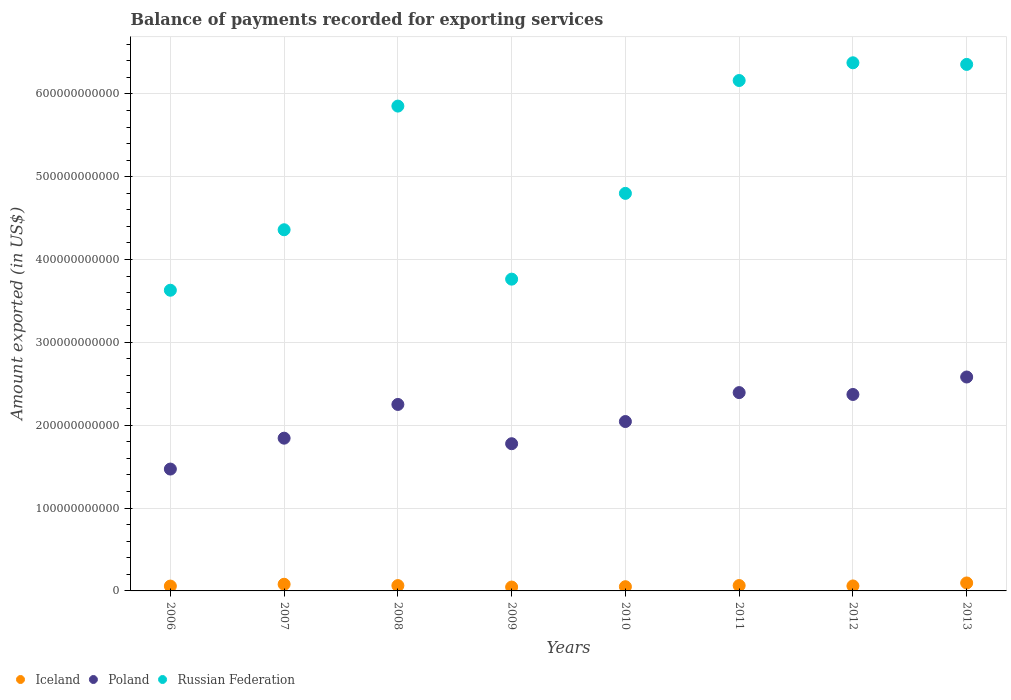How many different coloured dotlines are there?
Your answer should be very brief. 3. What is the amount exported in Russian Federation in 2012?
Offer a terse response. 6.38e+11. Across all years, what is the maximum amount exported in Poland?
Ensure brevity in your answer.  2.58e+11. Across all years, what is the minimum amount exported in Iceland?
Provide a succinct answer. 4.67e+09. In which year was the amount exported in Iceland maximum?
Provide a short and direct response. 2013. In which year was the amount exported in Poland minimum?
Offer a terse response. 2006. What is the total amount exported in Iceland in the graph?
Offer a terse response. 5.22e+1. What is the difference between the amount exported in Russian Federation in 2008 and that in 2011?
Offer a terse response. -3.09e+1. What is the difference between the amount exported in Iceland in 2013 and the amount exported in Russian Federation in 2009?
Your response must be concise. -3.67e+11. What is the average amount exported in Iceland per year?
Provide a succinct answer. 6.52e+09. In the year 2007, what is the difference between the amount exported in Iceland and amount exported in Russian Federation?
Give a very brief answer. -4.28e+11. In how many years, is the amount exported in Poland greater than 400000000000 US$?
Provide a succinct answer. 0. What is the ratio of the amount exported in Iceland in 2007 to that in 2008?
Your response must be concise. 1.25. Is the amount exported in Iceland in 2007 less than that in 2013?
Your answer should be compact. Yes. Is the difference between the amount exported in Iceland in 2010 and 2013 greater than the difference between the amount exported in Russian Federation in 2010 and 2013?
Provide a succinct answer. Yes. What is the difference between the highest and the second highest amount exported in Poland?
Your response must be concise. 1.88e+1. What is the difference between the highest and the lowest amount exported in Iceland?
Offer a very short reply. 4.95e+09. Does the amount exported in Iceland monotonically increase over the years?
Provide a succinct answer. No. What is the difference between two consecutive major ticks on the Y-axis?
Make the answer very short. 1.00e+11. Does the graph contain any zero values?
Keep it short and to the point. No. How are the legend labels stacked?
Give a very brief answer. Horizontal. What is the title of the graph?
Keep it short and to the point. Balance of payments recorded for exporting services. What is the label or title of the X-axis?
Ensure brevity in your answer.  Years. What is the label or title of the Y-axis?
Your answer should be compact. Amount exported (in US$). What is the Amount exported (in US$) of Iceland in 2006?
Your answer should be very brief. 5.86e+09. What is the Amount exported (in US$) of Poland in 2006?
Give a very brief answer. 1.47e+11. What is the Amount exported (in US$) of Russian Federation in 2006?
Give a very brief answer. 3.63e+11. What is the Amount exported (in US$) in Iceland in 2007?
Provide a short and direct response. 8.03e+09. What is the Amount exported (in US$) in Poland in 2007?
Provide a short and direct response. 1.84e+11. What is the Amount exported (in US$) in Russian Federation in 2007?
Ensure brevity in your answer.  4.36e+11. What is the Amount exported (in US$) in Iceland in 2008?
Provide a short and direct response. 6.43e+09. What is the Amount exported (in US$) in Poland in 2008?
Keep it short and to the point. 2.25e+11. What is the Amount exported (in US$) in Russian Federation in 2008?
Provide a succinct answer. 5.85e+11. What is the Amount exported (in US$) in Iceland in 2009?
Make the answer very short. 4.67e+09. What is the Amount exported (in US$) of Poland in 2009?
Provide a short and direct response. 1.78e+11. What is the Amount exported (in US$) in Russian Federation in 2009?
Ensure brevity in your answer.  3.76e+11. What is the Amount exported (in US$) of Iceland in 2010?
Ensure brevity in your answer.  5.08e+09. What is the Amount exported (in US$) of Poland in 2010?
Ensure brevity in your answer.  2.04e+11. What is the Amount exported (in US$) of Russian Federation in 2010?
Keep it short and to the point. 4.80e+11. What is the Amount exported (in US$) of Iceland in 2011?
Provide a short and direct response. 6.49e+09. What is the Amount exported (in US$) of Poland in 2011?
Your answer should be compact. 2.39e+11. What is the Amount exported (in US$) in Russian Federation in 2011?
Offer a terse response. 6.16e+11. What is the Amount exported (in US$) in Iceland in 2012?
Offer a very short reply. 6.00e+09. What is the Amount exported (in US$) in Poland in 2012?
Keep it short and to the point. 2.37e+11. What is the Amount exported (in US$) of Russian Federation in 2012?
Your response must be concise. 6.38e+11. What is the Amount exported (in US$) of Iceland in 2013?
Provide a succinct answer. 9.62e+09. What is the Amount exported (in US$) in Poland in 2013?
Keep it short and to the point. 2.58e+11. What is the Amount exported (in US$) of Russian Federation in 2013?
Your response must be concise. 6.36e+11. Across all years, what is the maximum Amount exported (in US$) in Iceland?
Provide a short and direct response. 9.62e+09. Across all years, what is the maximum Amount exported (in US$) in Poland?
Give a very brief answer. 2.58e+11. Across all years, what is the maximum Amount exported (in US$) in Russian Federation?
Ensure brevity in your answer.  6.38e+11. Across all years, what is the minimum Amount exported (in US$) of Iceland?
Provide a short and direct response. 4.67e+09. Across all years, what is the minimum Amount exported (in US$) in Poland?
Provide a succinct answer. 1.47e+11. Across all years, what is the minimum Amount exported (in US$) in Russian Federation?
Offer a very short reply. 3.63e+11. What is the total Amount exported (in US$) of Iceland in the graph?
Ensure brevity in your answer.  5.22e+1. What is the total Amount exported (in US$) of Poland in the graph?
Provide a succinct answer. 1.67e+12. What is the total Amount exported (in US$) in Russian Federation in the graph?
Your answer should be very brief. 4.13e+12. What is the difference between the Amount exported (in US$) in Iceland in 2006 and that in 2007?
Offer a terse response. -2.17e+09. What is the difference between the Amount exported (in US$) of Poland in 2006 and that in 2007?
Ensure brevity in your answer.  -3.73e+1. What is the difference between the Amount exported (in US$) in Russian Federation in 2006 and that in 2007?
Provide a short and direct response. -7.30e+1. What is the difference between the Amount exported (in US$) in Iceland in 2006 and that in 2008?
Make the answer very short. -5.76e+08. What is the difference between the Amount exported (in US$) of Poland in 2006 and that in 2008?
Your answer should be very brief. -7.80e+1. What is the difference between the Amount exported (in US$) of Russian Federation in 2006 and that in 2008?
Your response must be concise. -2.22e+11. What is the difference between the Amount exported (in US$) in Iceland in 2006 and that in 2009?
Ensure brevity in your answer.  1.19e+09. What is the difference between the Amount exported (in US$) in Poland in 2006 and that in 2009?
Offer a terse response. -3.06e+1. What is the difference between the Amount exported (in US$) in Russian Federation in 2006 and that in 2009?
Offer a very short reply. -1.34e+1. What is the difference between the Amount exported (in US$) of Iceland in 2006 and that in 2010?
Your answer should be compact. 7.73e+08. What is the difference between the Amount exported (in US$) in Poland in 2006 and that in 2010?
Provide a succinct answer. -5.74e+1. What is the difference between the Amount exported (in US$) in Russian Federation in 2006 and that in 2010?
Your answer should be compact. -1.17e+11. What is the difference between the Amount exported (in US$) in Iceland in 2006 and that in 2011?
Offer a terse response. -6.27e+08. What is the difference between the Amount exported (in US$) of Poland in 2006 and that in 2011?
Ensure brevity in your answer.  -9.23e+1. What is the difference between the Amount exported (in US$) of Russian Federation in 2006 and that in 2011?
Provide a short and direct response. -2.53e+11. What is the difference between the Amount exported (in US$) in Iceland in 2006 and that in 2012?
Give a very brief answer. -1.45e+08. What is the difference between the Amount exported (in US$) of Poland in 2006 and that in 2012?
Your response must be concise. -9.00e+1. What is the difference between the Amount exported (in US$) in Russian Federation in 2006 and that in 2012?
Ensure brevity in your answer.  -2.75e+11. What is the difference between the Amount exported (in US$) of Iceland in 2006 and that in 2013?
Provide a short and direct response. -3.76e+09. What is the difference between the Amount exported (in US$) in Poland in 2006 and that in 2013?
Offer a terse response. -1.11e+11. What is the difference between the Amount exported (in US$) in Russian Federation in 2006 and that in 2013?
Provide a short and direct response. -2.73e+11. What is the difference between the Amount exported (in US$) of Iceland in 2007 and that in 2008?
Your response must be concise. 1.60e+09. What is the difference between the Amount exported (in US$) of Poland in 2007 and that in 2008?
Your response must be concise. -4.07e+1. What is the difference between the Amount exported (in US$) in Russian Federation in 2007 and that in 2008?
Your answer should be compact. -1.49e+11. What is the difference between the Amount exported (in US$) in Iceland in 2007 and that in 2009?
Your answer should be compact. 3.36e+09. What is the difference between the Amount exported (in US$) of Poland in 2007 and that in 2009?
Offer a very short reply. 6.70e+09. What is the difference between the Amount exported (in US$) of Russian Federation in 2007 and that in 2009?
Give a very brief answer. 5.96e+1. What is the difference between the Amount exported (in US$) in Iceland in 2007 and that in 2010?
Provide a short and direct response. 2.94e+09. What is the difference between the Amount exported (in US$) of Poland in 2007 and that in 2010?
Make the answer very short. -2.01e+1. What is the difference between the Amount exported (in US$) in Russian Federation in 2007 and that in 2010?
Your answer should be compact. -4.39e+1. What is the difference between the Amount exported (in US$) in Iceland in 2007 and that in 2011?
Your response must be concise. 1.54e+09. What is the difference between the Amount exported (in US$) of Poland in 2007 and that in 2011?
Make the answer very short. -5.50e+1. What is the difference between the Amount exported (in US$) in Russian Federation in 2007 and that in 2011?
Make the answer very short. -1.80e+11. What is the difference between the Amount exported (in US$) of Iceland in 2007 and that in 2012?
Offer a terse response. 2.03e+09. What is the difference between the Amount exported (in US$) in Poland in 2007 and that in 2012?
Provide a short and direct response. -5.28e+1. What is the difference between the Amount exported (in US$) in Russian Federation in 2007 and that in 2012?
Make the answer very short. -2.02e+11. What is the difference between the Amount exported (in US$) of Iceland in 2007 and that in 2013?
Give a very brief answer. -1.59e+09. What is the difference between the Amount exported (in US$) in Poland in 2007 and that in 2013?
Your answer should be compact. -7.38e+1. What is the difference between the Amount exported (in US$) of Russian Federation in 2007 and that in 2013?
Your answer should be very brief. -2.00e+11. What is the difference between the Amount exported (in US$) in Iceland in 2008 and that in 2009?
Your answer should be compact. 1.77e+09. What is the difference between the Amount exported (in US$) in Poland in 2008 and that in 2009?
Provide a short and direct response. 4.74e+1. What is the difference between the Amount exported (in US$) in Russian Federation in 2008 and that in 2009?
Provide a succinct answer. 2.09e+11. What is the difference between the Amount exported (in US$) in Iceland in 2008 and that in 2010?
Keep it short and to the point. 1.35e+09. What is the difference between the Amount exported (in US$) of Poland in 2008 and that in 2010?
Ensure brevity in your answer.  2.06e+1. What is the difference between the Amount exported (in US$) of Russian Federation in 2008 and that in 2010?
Your answer should be very brief. 1.05e+11. What is the difference between the Amount exported (in US$) of Iceland in 2008 and that in 2011?
Make the answer very short. -5.18e+07. What is the difference between the Amount exported (in US$) of Poland in 2008 and that in 2011?
Give a very brief answer. -1.43e+1. What is the difference between the Amount exported (in US$) of Russian Federation in 2008 and that in 2011?
Offer a very short reply. -3.09e+1. What is the difference between the Amount exported (in US$) in Iceland in 2008 and that in 2012?
Ensure brevity in your answer.  4.31e+08. What is the difference between the Amount exported (in US$) in Poland in 2008 and that in 2012?
Your answer should be compact. -1.20e+1. What is the difference between the Amount exported (in US$) in Russian Federation in 2008 and that in 2012?
Your response must be concise. -5.23e+1. What is the difference between the Amount exported (in US$) of Iceland in 2008 and that in 2013?
Make the answer very short. -3.18e+09. What is the difference between the Amount exported (in US$) in Poland in 2008 and that in 2013?
Make the answer very short. -3.31e+1. What is the difference between the Amount exported (in US$) of Russian Federation in 2008 and that in 2013?
Offer a very short reply. -5.03e+1. What is the difference between the Amount exported (in US$) in Iceland in 2009 and that in 2010?
Provide a succinct answer. -4.17e+08. What is the difference between the Amount exported (in US$) of Poland in 2009 and that in 2010?
Keep it short and to the point. -2.68e+1. What is the difference between the Amount exported (in US$) of Russian Federation in 2009 and that in 2010?
Keep it short and to the point. -1.04e+11. What is the difference between the Amount exported (in US$) of Iceland in 2009 and that in 2011?
Give a very brief answer. -1.82e+09. What is the difference between the Amount exported (in US$) of Poland in 2009 and that in 2011?
Offer a very short reply. -6.17e+1. What is the difference between the Amount exported (in US$) in Russian Federation in 2009 and that in 2011?
Offer a terse response. -2.40e+11. What is the difference between the Amount exported (in US$) in Iceland in 2009 and that in 2012?
Keep it short and to the point. -1.33e+09. What is the difference between the Amount exported (in US$) in Poland in 2009 and that in 2012?
Your answer should be very brief. -5.95e+1. What is the difference between the Amount exported (in US$) of Russian Federation in 2009 and that in 2012?
Ensure brevity in your answer.  -2.61e+11. What is the difference between the Amount exported (in US$) in Iceland in 2009 and that in 2013?
Make the answer very short. -4.95e+09. What is the difference between the Amount exported (in US$) of Poland in 2009 and that in 2013?
Your answer should be very brief. -8.05e+1. What is the difference between the Amount exported (in US$) in Russian Federation in 2009 and that in 2013?
Your response must be concise. -2.59e+11. What is the difference between the Amount exported (in US$) of Iceland in 2010 and that in 2011?
Your response must be concise. -1.40e+09. What is the difference between the Amount exported (in US$) of Poland in 2010 and that in 2011?
Your response must be concise. -3.49e+1. What is the difference between the Amount exported (in US$) in Russian Federation in 2010 and that in 2011?
Your response must be concise. -1.36e+11. What is the difference between the Amount exported (in US$) of Iceland in 2010 and that in 2012?
Your answer should be very brief. -9.18e+08. What is the difference between the Amount exported (in US$) of Poland in 2010 and that in 2012?
Offer a terse response. -3.27e+1. What is the difference between the Amount exported (in US$) in Russian Federation in 2010 and that in 2012?
Your response must be concise. -1.58e+11. What is the difference between the Amount exported (in US$) in Iceland in 2010 and that in 2013?
Your answer should be compact. -4.53e+09. What is the difference between the Amount exported (in US$) in Poland in 2010 and that in 2013?
Your answer should be very brief. -5.37e+1. What is the difference between the Amount exported (in US$) in Russian Federation in 2010 and that in 2013?
Give a very brief answer. -1.56e+11. What is the difference between the Amount exported (in US$) in Iceland in 2011 and that in 2012?
Offer a terse response. 4.83e+08. What is the difference between the Amount exported (in US$) of Poland in 2011 and that in 2012?
Ensure brevity in your answer.  2.25e+09. What is the difference between the Amount exported (in US$) in Russian Federation in 2011 and that in 2012?
Your answer should be very brief. -2.14e+1. What is the difference between the Amount exported (in US$) of Iceland in 2011 and that in 2013?
Offer a terse response. -3.13e+09. What is the difference between the Amount exported (in US$) of Poland in 2011 and that in 2013?
Provide a succinct answer. -1.88e+1. What is the difference between the Amount exported (in US$) in Russian Federation in 2011 and that in 2013?
Your answer should be compact. -1.94e+1. What is the difference between the Amount exported (in US$) of Iceland in 2012 and that in 2013?
Ensure brevity in your answer.  -3.61e+09. What is the difference between the Amount exported (in US$) in Poland in 2012 and that in 2013?
Give a very brief answer. -2.11e+1. What is the difference between the Amount exported (in US$) in Russian Federation in 2012 and that in 2013?
Make the answer very short. 1.96e+09. What is the difference between the Amount exported (in US$) in Iceland in 2006 and the Amount exported (in US$) in Poland in 2007?
Your answer should be compact. -1.79e+11. What is the difference between the Amount exported (in US$) in Iceland in 2006 and the Amount exported (in US$) in Russian Federation in 2007?
Make the answer very short. -4.30e+11. What is the difference between the Amount exported (in US$) of Poland in 2006 and the Amount exported (in US$) of Russian Federation in 2007?
Provide a short and direct response. -2.89e+11. What is the difference between the Amount exported (in US$) in Iceland in 2006 and the Amount exported (in US$) in Poland in 2008?
Keep it short and to the point. -2.19e+11. What is the difference between the Amount exported (in US$) of Iceland in 2006 and the Amount exported (in US$) of Russian Federation in 2008?
Your response must be concise. -5.79e+11. What is the difference between the Amount exported (in US$) in Poland in 2006 and the Amount exported (in US$) in Russian Federation in 2008?
Provide a succinct answer. -4.38e+11. What is the difference between the Amount exported (in US$) in Iceland in 2006 and the Amount exported (in US$) in Poland in 2009?
Your answer should be very brief. -1.72e+11. What is the difference between the Amount exported (in US$) of Iceland in 2006 and the Amount exported (in US$) of Russian Federation in 2009?
Make the answer very short. -3.70e+11. What is the difference between the Amount exported (in US$) in Poland in 2006 and the Amount exported (in US$) in Russian Federation in 2009?
Provide a short and direct response. -2.29e+11. What is the difference between the Amount exported (in US$) of Iceland in 2006 and the Amount exported (in US$) of Poland in 2010?
Ensure brevity in your answer.  -1.99e+11. What is the difference between the Amount exported (in US$) of Iceland in 2006 and the Amount exported (in US$) of Russian Federation in 2010?
Provide a succinct answer. -4.74e+11. What is the difference between the Amount exported (in US$) of Poland in 2006 and the Amount exported (in US$) of Russian Federation in 2010?
Provide a short and direct response. -3.33e+11. What is the difference between the Amount exported (in US$) of Iceland in 2006 and the Amount exported (in US$) of Poland in 2011?
Offer a very short reply. -2.34e+11. What is the difference between the Amount exported (in US$) of Iceland in 2006 and the Amount exported (in US$) of Russian Federation in 2011?
Provide a short and direct response. -6.10e+11. What is the difference between the Amount exported (in US$) of Poland in 2006 and the Amount exported (in US$) of Russian Federation in 2011?
Give a very brief answer. -4.69e+11. What is the difference between the Amount exported (in US$) of Iceland in 2006 and the Amount exported (in US$) of Poland in 2012?
Make the answer very short. -2.31e+11. What is the difference between the Amount exported (in US$) of Iceland in 2006 and the Amount exported (in US$) of Russian Federation in 2012?
Provide a succinct answer. -6.32e+11. What is the difference between the Amount exported (in US$) of Poland in 2006 and the Amount exported (in US$) of Russian Federation in 2012?
Your response must be concise. -4.90e+11. What is the difference between the Amount exported (in US$) of Iceland in 2006 and the Amount exported (in US$) of Poland in 2013?
Make the answer very short. -2.52e+11. What is the difference between the Amount exported (in US$) in Iceland in 2006 and the Amount exported (in US$) in Russian Federation in 2013?
Your response must be concise. -6.30e+11. What is the difference between the Amount exported (in US$) in Poland in 2006 and the Amount exported (in US$) in Russian Federation in 2013?
Offer a terse response. -4.88e+11. What is the difference between the Amount exported (in US$) in Iceland in 2007 and the Amount exported (in US$) in Poland in 2008?
Make the answer very short. -2.17e+11. What is the difference between the Amount exported (in US$) in Iceland in 2007 and the Amount exported (in US$) in Russian Federation in 2008?
Provide a short and direct response. -5.77e+11. What is the difference between the Amount exported (in US$) in Poland in 2007 and the Amount exported (in US$) in Russian Federation in 2008?
Ensure brevity in your answer.  -4.01e+11. What is the difference between the Amount exported (in US$) of Iceland in 2007 and the Amount exported (in US$) of Poland in 2009?
Your answer should be very brief. -1.70e+11. What is the difference between the Amount exported (in US$) of Iceland in 2007 and the Amount exported (in US$) of Russian Federation in 2009?
Provide a short and direct response. -3.68e+11. What is the difference between the Amount exported (in US$) in Poland in 2007 and the Amount exported (in US$) in Russian Federation in 2009?
Ensure brevity in your answer.  -1.92e+11. What is the difference between the Amount exported (in US$) of Iceland in 2007 and the Amount exported (in US$) of Poland in 2010?
Your response must be concise. -1.96e+11. What is the difference between the Amount exported (in US$) in Iceland in 2007 and the Amount exported (in US$) in Russian Federation in 2010?
Keep it short and to the point. -4.72e+11. What is the difference between the Amount exported (in US$) of Poland in 2007 and the Amount exported (in US$) of Russian Federation in 2010?
Offer a terse response. -2.96e+11. What is the difference between the Amount exported (in US$) in Iceland in 2007 and the Amount exported (in US$) in Poland in 2011?
Your answer should be compact. -2.31e+11. What is the difference between the Amount exported (in US$) in Iceland in 2007 and the Amount exported (in US$) in Russian Federation in 2011?
Offer a very short reply. -6.08e+11. What is the difference between the Amount exported (in US$) in Poland in 2007 and the Amount exported (in US$) in Russian Federation in 2011?
Your response must be concise. -4.32e+11. What is the difference between the Amount exported (in US$) of Iceland in 2007 and the Amount exported (in US$) of Poland in 2012?
Provide a succinct answer. -2.29e+11. What is the difference between the Amount exported (in US$) in Iceland in 2007 and the Amount exported (in US$) in Russian Federation in 2012?
Your response must be concise. -6.30e+11. What is the difference between the Amount exported (in US$) in Poland in 2007 and the Amount exported (in US$) in Russian Federation in 2012?
Your answer should be compact. -4.53e+11. What is the difference between the Amount exported (in US$) of Iceland in 2007 and the Amount exported (in US$) of Poland in 2013?
Provide a succinct answer. -2.50e+11. What is the difference between the Amount exported (in US$) of Iceland in 2007 and the Amount exported (in US$) of Russian Federation in 2013?
Provide a succinct answer. -6.28e+11. What is the difference between the Amount exported (in US$) of Poland in 2007 and the Amount exported (in US$) of Russian Federation in 2013?
Your answer should be compact. -4.51e+11. What is the difference between the Amount exported (in US$) of Iceland in 2008 and the Amount exported (in US$) of Poland in 2009?
Give a very brief answer. -1.71e+11. What is the difference between the Amount exported (in US$) of Iceland in 2008 and the Amount exported (in US$) of Russian Federation in 2009?
Keep it short and to the point. -3.70e+11. What is the difference between the Amount exported (in US$) of Poland in 2008 and the Amount exported (in US$) of Russian Federation in 2009?
Ensure brevity in your answer.  -1.51e+11. What is the difference between the Amount exported (in US$) in Iceland in 2008 and the Amount exported (in US$) in Poland in 2010?
Make the answer very short. -1.98e+11. What is the difference between the Amount exported (in US$) of Iceland in 2008 and the Amount exported (in US$) of Russian Federation in 2010?
Keep it short and to the point. -4.73e+11. What is the difference between the Amount exported (in US$) of Poland in 2008 and the Amount exported (in US$) of Russian Federation in 2010?
Your answer should be compact. -2.55e+11. What is the difference between the Amount exported (in US$) in Iceland in 2008 and the Amount exported (in US$) in Poland in 2011?
Offer a terse response. -2.33e+11. What is the difference between the Amount exported (in US$) in Iceland in 2008 and the Amount exported (in US$) in Russian Federation in 2011?
Give a very brief answer. -6.10e+11. What is the difference between the Amount exported (in US$) in Poland in 2008 and the Amount exported (in US$) in Russian Federation in 2011?
Keep it short and to the point. -3.91e+11. What is the difference between the Amount exported (in US$) of Iceland in 2008 and the Amount exported (in US$) of Poland in 2012?
Make the answer very short. -2.31e+11. What is the difference between the Amount exported (in US$) in Iceland in 2008 and the Amount exported (in US$) in Russian Federation in 2012?
Offer a very short reply. -6.31e+11. What is the difference between the Amount exported (in US$) in Poland in 2008 and the Amount exported (in US$) in Russian Federation in 2012?
Give a very brief answer. -4.12e+11. What is the difference between the Amount exported (in US$) of Iceland in 2008 and the Amount exported (in US$) of Poland in 2013?
Keep it short and to the point. -2.52e+11. What is the difference between the Amount exported (in US$) in Iceland in 2008 and the Amount exported (in US$) in Russian Federation in 2013?
Offer a terse response. -6.29e+11. What is the difference between the Amount exported (in US$) of Poland in 2008 and the Amount exported (in US$) of Russian Federation in 2013?
Your answer should be compact. -4.10e+11. What is the difference between the Amount exported (in US$) of Iceland in 2009 and the Amount exported (in US$) of Poland in 2010?
Keep it short and to the point. -2.00e+11. What is the difference between the Amount exported (in US$) of Iceland in 2009 and the Amount exported (in US$) of Russian Federation in 2010?
Give a very brief answer. -4.75e+11. What is the difference between the Amount exported (in US$) of Poland in 2009 and the Amount exported (in US$) of Russian Federation in 2010?
Keep it short and to the point. -3.02e+11. What is the difference between the Amount exported (in US$) of Iceland in 2009 and the Amount exported (in US$) of Poland in 2011?
Make the answer very short. -2.35e+11. What is the difference between the Amount exported (in US$) in Iceland in 2009 and the Amount exported (in US$) in Russian Federation in 2011?
Your answer should be very brief. -6.11e+11. What is the difference between the Amount exported (in US$) of Poland in 2009 and the Amount exported (in US$) of Russian Federation in 2011?
Provide a short and direct response. -4.38e+11. What is the difference between the Amount exported (in US$) in Iceland in 2009 and the Amount exported (in US$) in Poland in 2012?
Offer a very short reply. -2.32e+11. What is the difference between the Amount exported (in US$) of Iceland in 2009 and the Amount exported (in US$) of Russian Federation in 2012?
Provide a succinct answer. -6.33e+11. What is the difference between the Amount exported (in US$) of Poland in 2009 and the Amount exported (in US$) of Russian Federation in 2012?
Ensure brevity in your answer.  -4.60e+11. What is the difference between the Amount exported (in US$) in Iceland in 2009 and the Amount exported (in US$) in Poland in 2013?
Make the answer very short. -2.54e+11. What is the difference between the Amount exported (in US$) of Iceland in 2009 and the Amount exported (in US$) of Russian Federation in 2013?
Make the answer very short. -6.31e+11. What is the difference between the Amount exported (in US$) in Poland in 2009 and the Amount exported (in US$) in Russian Federation in 2013?
Ensure brevity in your answer.  -4.58e+11. What is the difference between the Amount exported (in US$) in Iceland in 2010 and the Amount exported (in US$) in Poland in 2011?
Provide a succinct answer. -2.34e+11. What is the difference between the Amount exported (in US$) in Iceland in 2010 and the Amount exported (in US$) in Russian Federation in 2011?
Offer a very short reply. -6.11e+11. What is the difference between the Amount exported (in US$) of Poland in 2010 and the Amount exported (in US$) of Russian Federation in 2011?
Offer a very short reply. -4.12e+11. What is the difference between the Amount exported (in US$) of Iceland in 2010 and the Amount exported (in US$) of Poland in 2012?
Keep it short and to the point. -2.32e+11. What is the difference between the Amount exported (in US$) of Iceland in 2010 and the Amount exported (in US$) of Russian Federation in 2012?
Give a very brief answer. -6.32e+11. What is the difference between the Amount exported (in US$) in Poland in 2010 and the Amount exported (in US$) in Russian Federation in 2012?
Your response must be concise. -4.33e+11. What is the difference between the Amount exported (in US$) of Iceland in 2010 and the Amount exported (in US$) of Poland in 2013?
Your answer should be very brief. -2.53e+11. What is the difference between the Amount exported (in US$) of Iceland in 2010 and the Amount exported (in US$) of Russian Federation in 2013?
Give a very brief answer. -6.30e+11. What is the difference between the Amount exported (in US$) of Poland in 2010 and the Amount exported (in US$) of Russian Federation in 2013?
Provide a succinct answer. -4.31e+11. What is the difference between the Amount exported (in US$) in Iceland in 2011 and the Amount exported (in US$) in Poland in 2012?
Your response must be concise. -2.31e+11. What is the difference between the Amount exported (in US$) in Iceland in 2011 and the Amount exported (in US$) in Russian Federation in 2012?
Provide a short and direct response. -6.31e+11. What is the difference between the Amount exported (in US$) of Poland in 2011 and the Amount exported (in US$) of Russian Federation in 2012?
Your answer should be compact. -3.98e+11. What is the difference between the Amount exported (in US$) of Iceland in 2011 and the Amount exported (in US$) of Poland in 2013?
Offer a very short reply. -2.52e+11. What is the difference between the Amount exported (in US$) of Iceland in 2011 and the Amount exported (in US$) of Russian Federation in 2013?
Offer a very short reply. -6.29e+11. What is the difference between the Amount exported (in US$) of Poland in 2011 and the Amount exported (in US$) of Russian Federation in 2013?
Make the answer very short. -3.96e+11. What is the difference between the Amount exported (in US$) in Iceland in 2012 and the Amount exported (in US$) in Poland in 2013?
Your answer should be compact. -2.52e+11. What is the difference between the Amount exported (in US$) of Iceland in 2012 and the Amount exported (in US$) of Russian Federation in 2013?
Provide a succinct answer. -6.30e+11. What is the difference between the Amount exported (in US$) of Poland in 2012 and the Amount exported (in US$) of Russian Federation in 2013?
Your response must be concise. -3.98e+11. What is the average Amount exported (in US$) in Iceland per year?
Make the answer very short. 6.52e+09. What is the average Amount exported (in US$) in Poland per year?
Your answer should be very brief. 2.09e+11. What is the average Amount exported (in US$) of Russian Federation per year?
Give a very brief answer. 5.16e+11. In the year 2006, what is the difference between the Amount exported (in US$) of Iceland and Amount exported (in US$) of Poland?
Give a very brief answer. -1.41e+11. In the year 2006, what is the difference between the Amount exported (in US$) of Iceland and Amount exported (in US$) of Russian Federation?
Your answer should be compact. -3.57e+11. In the year 2006, what is the difference between the Amount exported (in US$) in Poland and Amount exported (in US$) in Russian Federation?
Offer a terse response. -2.16e+11. In the year 2007, what is the difference between the Amount exported (in US$) of Iceland and Amount exported (in US$) of Poland?
Your answer should be very brief. -1.76e+11. In the year 2007, what is the difference between the Amount exported (in US$) in Iceland and Amount exported (in US$) in Russian Federation?
Your answer should be very brief. -4.28e+11. In the year 2007, what is the difference between the Amount exported (in US$) of Poland and Amount exported (in US$) of Russian Federation?
Provide a short and direct response. -2.52e+11. In the year 2008, what is the difference between the Amount exported (in US$) of Iceland and Amount exported (in US$) of Poland?
Provide a short and direct response. -2.19e+11. In the year 2008, what is the difference between the Amount exported (in US$) of Iceland and Amount exported (in US$) of Russian Federation?
Offer a very short reply. -5.79e+11. In the year 2008, what is the difference between the Amount exported (in US$) of Poland and Amount exported (in US$) of Russian Federation?
Your answer should be compact. -3.60e+11. In the year 2009, what is the difference between the Amount exported (in US$) in Iceland and Amount exported (in US$) in Poland?
Make the answer very short. -1.73e+11. In the year 2009, what is the difference between the Amount exported (in US$) of Iceland and Amount exported (in US$) of Russian Federation?
Your response must be concise. -3.72e+11. In the year 2009, what is the difference between the Amount exported (in US$) in Poland and Amount exported (in US$) in Russian Federation?
Give a very brief answer. -1.99e+11. In the year 2010, what is the difference between the Amount exported (in US$) of Iceland and Amount exported (in US$) of Poland?
Ensure brevity in your answer.  -1.99e+11. In the year 2010, what is the difference between the Amount exported (in US$) in Iceland and Amount exported (in US$) in Russian Federation?
Your response must be concise. -4.75e+11. In the year 2010, what is the difference between the Amount exported (in US$) in Poland and Amount exported (in US$) in Russian Federation?
Your response must be concise. -2.75e+11. In the year 2011, what is the difference between the Amount exported (in US$) in Iceland and Amount exported (in US$) in Poland?
Provide a short and direct response. -2.33e+11. In the year 2011, what is the difference between the Amount exported (in US$) in Iceland and Amount exported (in US$) in Russian Federation?
Make the answer very short. -6.10e+11. In the year 2011, what is the difference between the Amount exported (in US$) in Poland and Amount exported (in US$) in Russian Federation?
Provide a short and direct response. -3.77e+11. In the year 2012, what is the difference between the Amount exported (in US$) of Iceland and Amount exported (in US$) of Poland?
Offer a very short reply. -2.31e+11. In the year 2012, what is the difference between the Amount exported (in US$) in Iceland and Amount exported (in US$) in Russian Federation?
Offer a very short reply. -6.32e+11. In the year 2012, what is the difference between the Amount exported (in US$) of Poland and Amount exported (in US$) of Russian Federation?
Give a very brief answer. -4.00e+11. In the year 2013, what is the difference between the Amount exported (in US$) of Iceland and Amount exported (in US$) of Poland?
Provide a short and direct response. -2.49e+11. In the year 2013, what is the difference between the Amount exported (in US$) in Iceland and Amount exported (in US$) in Russian Federation?
Make the answer very short. -6.26e+11. In the year 2013, what is the difference between the Amount exported (in US$) in Poland and Amount exported (in US$) in Russian Federation?
Make the answer very short. -3.77e+11. What is the ratio of the Amount exported (in US$) in Iceland in 2006 to that in 2007?
Ensure brevity in your answer.  0.73. What is the ratio of the Amount exported (in US$) in Poland in 2006 to that in 2007?
Provide a short and direct response. 0.8. What is the ratio of the Amount exported (in US$) in Russian Federation in 2006 to that in 2007?
Offer a very short reply. 0.83. What is the ratio of the Amount exported (in US$) of Iceland in 2006 to that in 2008?
Offer a very short reply. 0.91. What is the ratio of the Amount exported (in US$) in Poland in 2006 to that in 2008?
Provide a succinct answer. 0.65. What is the ratio of the Amount exported (in US$) of Russian Federation in 2006 to that in 2008?
Your answer should be very brief. 0.62. What is the ratio of the Amount exported (in US$) of Iceland in 2006 to that in 2009?
Offer a terse response. 1.25. What is the ratio of the Amount exported (in US$) in Poland in 2006 to that in 2009?
Your answer should be compact. 0.83. What is the ratio of the Amount exported (in US$) in Russian Federation in 2006 to that in 2009?
Your answer should be compact. 0.96. What is the ratio of the Amount exported (in US$) in Iceland in 2006 to that in 2010?
Provide a succinct answer. 1.15. What is the ratio of the Amount exported (in US$) in Poland in 2006 to that in 2010?
Give a very brief answer. 0.72. What is the ratio of the Amount exported (in US$) of Russian Federation in 2006 to that in 2010?
Make the answer very short. 0.76. What is the ratio of the Amount exported (in US$) in Iceland in 2006 to that in 2011?
Offer a terse response. 0.9. What is the ratio of the Amount exported (in US$) in Poland in 2006 to that in 2011?
Your answer should be compact. 0.61. What is the ratio of the Amount exported (in US$) in Russian Federation in 2006 to that in 2011?
Ensure brevity in your answer.  0.59. What is the ratio of the Amount exported (in US$) in Iceland in 2006 to that in 2012?
Your response must be concise. 0.98. What is the ratio of the Amount exported (in US$) in Poland in 2006 to that in 2012?
Offer a very short reply. 0.62. What is the ratio of the Amount exported (in US$) in Russian Federation in 2006 to that in 2012?
Offer a very short reply. 0.57. What is the ratio of the Amount exported (in US$) in Iceland in 2006 to that in 2013?
Your response must be concise. 0.61. What is the ratio of the Amount exported (in US$) in Poland in 2006 to that in 2013?
Ensure brevity in your answer.  0.57. What is the ratio of the Amount exported (in US$) in Russian Federation in 2006 to that in 2013?
Your answer should be very brief. 0.57. What is the ratio of the Amount exported (in US$) in Iceland in 2007 to that in 2008?
Offer a very short reply. 1.25. What is the ratio of the Amount exported (in US$) of Poland in 2007 to that in 2008?
Give a very brief answer. 0.82. What is the ratio of the Amount exported (in US$) in Russian Federation in 2007 to that in 2008?
Give a very brief answer. 0.74. What is the ratio of the Amount exported (in US$) of Iceland in 2007 to that in 2009?
Make the answer very short. 1.72. What is the ratio of the Amount exported (in US$) in Poland in 2007 to that in 2009?
Keep it short and to the point. 1.04. What is the ratio of the Amount exported (in US$) of Russian Federation in 2007 to that in 2009?
Offer a very short reply. 1.16. What is the ratio of the Amount exported (in US$) of Iceland in 2007 to that in 2010?
Your response must be concise. 1.58. What is the ratio of the Amount exported (in US$) in Poland in 2007 to that in 2010?
Provide a succinct answer. 0.9. What is the ratio of the Amount exported (in US$) of Russian Federation in 2007 to that in 2010?
Provide a succinct answer. 0.91. What is the ratio of the Amount exported (in US$) of Iceland in 2007 to that in 2011?
Your answer should be very brief. 1.24. What is the ratio of the Amount exported (in US$) in Poland in 2007 to that in 2011?
Make the answer very short. 0.77. What is the ratio of the Amount exported (in US$) of Russian Federation in 2007 to that in 2011?
Make the answer very short. 0.71. What is the ratio of the Amount exported (in US$) in Iceland in 2007 to that in 2012?
Give a very brief answer. 1.34. What is the ratio of the Amount exported (in US$) in Poland in 2007 to that in 2012?
Give a very brief answer. 0.78. What is the ratio of the Amount exported (in US$) in Russian Federation in 2007 to that in 2012?
Your response must be concise. 0.68. What is the ratio of the Amount exported (in US$) in Iceland in 2007 to that in 2013?
Provide a short and direct response. 0.84. What is the ratio of the Amount exported (in US$) in Poland in 2007 to that in 2013?
Your answer should be compact. 0.71. What is the ratio of the Amount exported (in US$) of Russian Federation in 2007 to that in 2013?
Offer a terse response. 0.69. What is the ratio of the Amount exported (in US$) in Iceland in 2008 to that in 2009?
Offer a terse response. 1.38. What is the ratio of the Amount exported (in US$) in Poland in 2008 to that in 2009?
Offer a very short reply. 1.27. What is the ratio of the Amount exported (in US$) in Russian Federation in 2008 to that in 2009?
Keep it short and to the point. 1.56. What is the ratio of the Amount exported (in US$) of Iceland in 2008 to that in 2010?
Your answer should be very brief. 1.27. What is the ratio of the Amount exported (in US$) in Poland in 2008 to that in 2010?
Make the answer very short. 1.1. What is the ratio of the Amount exported (in US$) of Russian Federation in 2008 to that in 2010?
Offer a terse response. 1.22. What is the ratio of the Amount exported (in US$) of Iceland in 2008 to that in 2011?
Give a very brief answer. 0.99. What is the ratio of the Amount exported (in US$) of Poland in 2008 to that in 2011?
Provide a succinct answer. 0.94. What is the ratio of the Amount exported (in US$) in Russian Federation in 2008 to that in 2011?
Ensure brevity in your answer.  0.95. What is the ratio of the Amount exported (in US$) of Iceland in 2008 to that in 2012?
Offer a terse response. 1.07. What is the ratio of the Amount exported (in US$) in Poland in 2008 to that in 2012?
Make the answer very short. 0.95. What is the ratio of the Amount exported (in US$) in Russian Federation in 2008 to that in 2012?
Your response must be concise. 0.92. What is the ratio of the Amount exported (in US$) of Iceland in 2008 to that in 2013?
Your answer should be very brief. 0.67. What is the ratio of the Amount exported (in US$) in Poland in 2008 to that in 2013?
Give a very brief answer. 0.87. What is the ratio of the Amount exported (in US$) of Russian Federation in 2008 to that in 2013?
Offer a terse response. 0.92. What is the ratio of the Amount exported (in US$) of Iceland in 2009 to that in 2010?
Offer a terse response. 0.92. What is the ratio of the Amount exported (in US$) in Poland in 2009 to that in 2010?
Your answer should be compact. 0.87. What is the ratio of the Amount exported (in US$) of Russian Federation in 2009 to that in 2010?
Your response must be concise. 0.78. What is the ratio of the Amount exported (in US$) of Iceland in 2009 to that in 2011?
Your answer should be very brief. 0.72. What is the ratio of the Amount exported (in US$) of Poland in 2009 to that in 2011?
Give a very brief answer. 0.74. What is the ratio of the Amount exported (in US$) of Russian Federation in 2009 to that in 2011?
Ensure brevity in your answer.  0.61. What is the ratio of the Amount exported (in US$) in Iceland in 2009 to that in 2012?
Make the answer very short. 0.78. What is the ratio of the Amount exported (in US$) in Poland in 2009 to that in 2012?
Offer a very short reply. 0.75. What is the ratio of the Amount exported (in US$) in Russian Federation in 2009 to that in 2012?
Your answer should be compact. 0.59. What is the ratio of the Amount exported (in US$) of Iceland in 2009 to that in 2013?
Offer a terse response. 0.49. What is the ratio of the Amount exported (in US$) of Poland in 2009 to that in 2013?
Keep it short and to the point. 0.69. What is the ratio of the Amount exported (in US$) in Russian Federation in 2009 to that in 2013?
Your answer should be very brief. 0.59. What is the ratio of the Amount exported (in US$) of Iceland in 2010 to that in 2011?
Your answer should be compact. 0.78. What is the ratio of the Amount exported (in US$) in Poland in 2010 to that in 2011?
Give a very brief answer. 0.85. What is the ratio of the Amount exported (in US$) of Russian Federation in 2010 to that in 2011?
Make the answer very short. 0.78. What is the ratio of the Amount exported (in US$) of Iceland in 2010 to that in 2012?
Ensure brevity in your answer.  0.85. What is the ratio of the Amount exported (in US$) of Poland in 2010 to that in 2012?
Ensure brevity in your answer.  0.86. What is the ratio of the Amount exported (in US$) of Russian Federation in 2010 to that in 2012?
Your response must be concise. 0.75. What is the ratio of the Amount exported (in US$) in Iceland in 2010 to that in 2013?
Provide a succinct answer. 0.53. What is the ratio of the Amount exported (in US$) of Poland in 2010 to that in 2013?
Your answer should be very brief. 0.79. What is the ratio of the Amount exported (in US$) in Russian Federation in 2010 to that in 2013?
Provide a succinct answer. 0.76. What is the ratio of the Amount exported (in US$) of Iceland in 2011 to that in 2012?
Provide a succinct answer. 1.08. What is the ratio of the Amount exported (in US$) in Poland in 2011 to that in 2012?
Your response must be concise. 1.01. What is the ratio of the Amount exported (in US$) in Russian Federation in 2011 to that in 2012?
Provide a succinct answer. 0.97. What is the ratio of the Amount exported (in US$) of Iceland in 2011 to that in 2013?
Your answer should be compact. 0.67. What is the ratio of the Amount exported (in US$) of Poland in 2011 to that in 2013?
Keep it short and to the point. 0.93. What is the ratio of the Amount exported (in US$) in Russian Federation in 2011 to that in 2013?
Offer a terse response. 0.97. What is the ratio of the Amount exported (in US$) of Iceland in 2012 to that in 2013?
Your answer should be very brief. 0.62. What is the ratio of the Amount exported (in US$) of Poland in 2012 to that in 2013?
Offer a very short reply. 0.92. What is the ratio of the Amount exported (in US$) in Russian Federation in 2012 to that in 2013?
Your response must be concise. 1. What is the difference between the highest and the second highest Amount exported (in US$) of Iceland?
Provide a succinct answer. 1.59e+09. What is the difference between the highest and the second highest Amount exported (in US$) in Poland?
Make the answer very short. 1.88e+1. What is the difference between the highest and the second highest Amount exported (in US$) of Russian Federation?
Provide a short and direct response. 1.96e+09. What is the difference between the highest and the lowest Amount exported (in US$) in Iceland?
Your response must be concise. 4.95e+09. What is the difference between the highest and the lowest Amount exported (in US$) in Poland?
Your answer should be very brief. 1.11e+11. What is the difference between the highest and the lowest Amount exported (in US$) of Russian Federation?
Provide a succinct answer. 2.75e+11. 